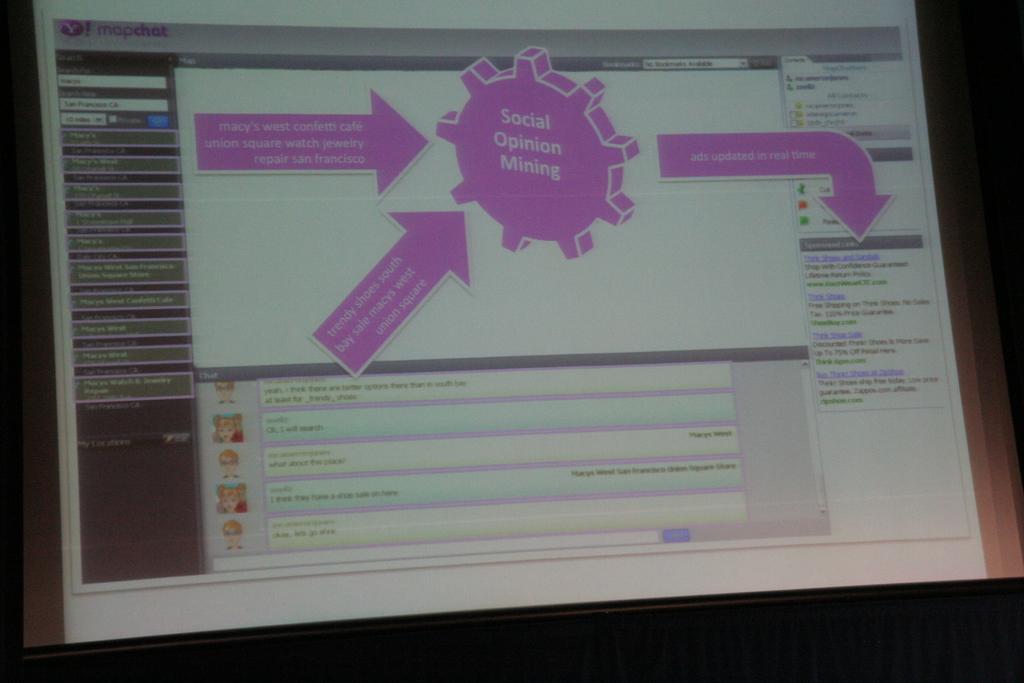What is written in the purple shape?
Make the answer very short. Social opinion mining. 